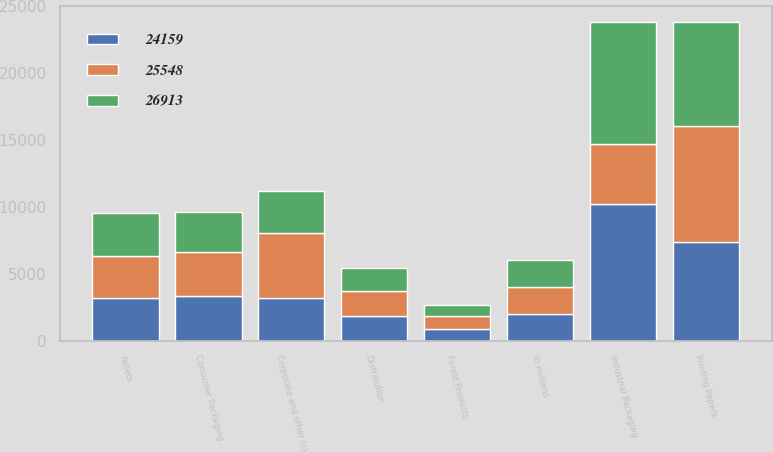Convert chart. <chart><loc_0><loc_0><loc_500><loc_500><stacked_bar_chart><ecel><fcel>In millions<fcel>Industrial Packaging<fcel>Printing Papers<fcel>Consumer Packaging<fcel>Distribution<fcel>Forest Products<fcel>Corporate and other (c)<fcel>Assets<nl><fcel>26913<fcel>2009<fcel>9120<fcel>7791<fcel>3000<fcel>1692<fcel>758<fcel>3187<fcel>3180<nl><fcel>24159<fcel>2008<fcel>10212<fcel>7396<fcel>3333<fcel>1881<fcel>903<fcel>3180<fcel>3180<nl><fcel>25548<fcel>2007<fcel>4486<fcel>8650<fcel>3285<fcel>1875<fcel>984<fcel>4867<fcel>3180<nl></chart> 